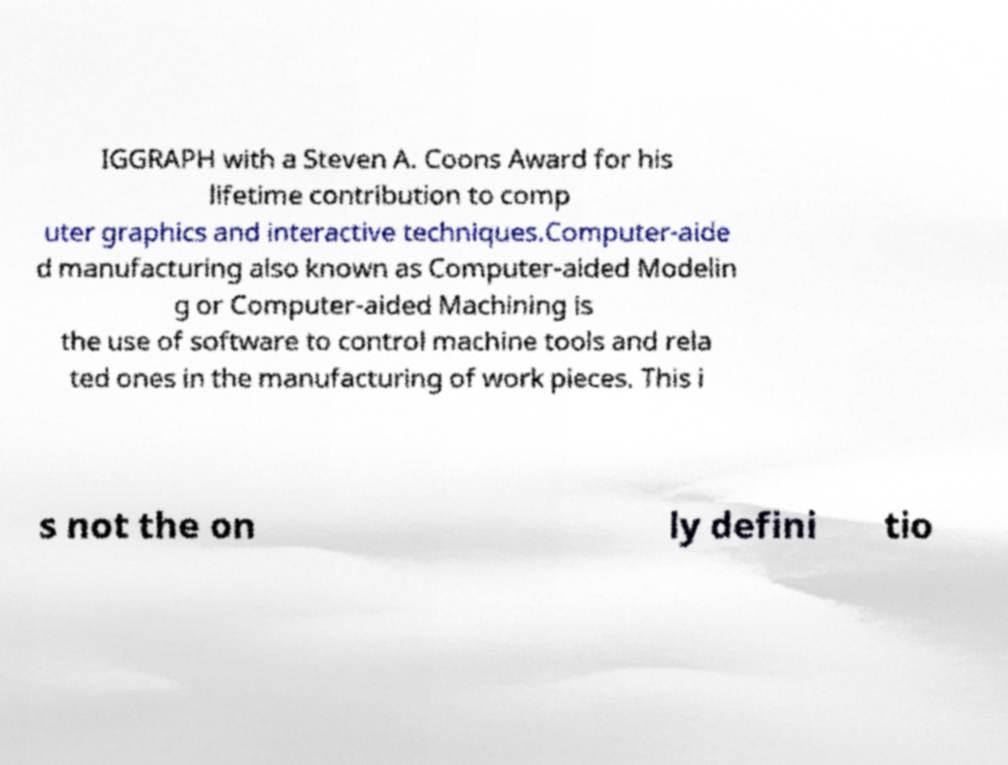What messages or text are displayed in this image? I need them in a readable, typed format. IGGRAPH with a Steven A. Coons Award for his lifetime contribution to comp uter graphics and interactive techniques.Computer-aide d manufacturing also known as Computer-aided Modelin g or Computer-aided Machining is the use of software to control machine tools and rela ted ones in the manufacturing of work pieces. This i s not the on ly defini tio 